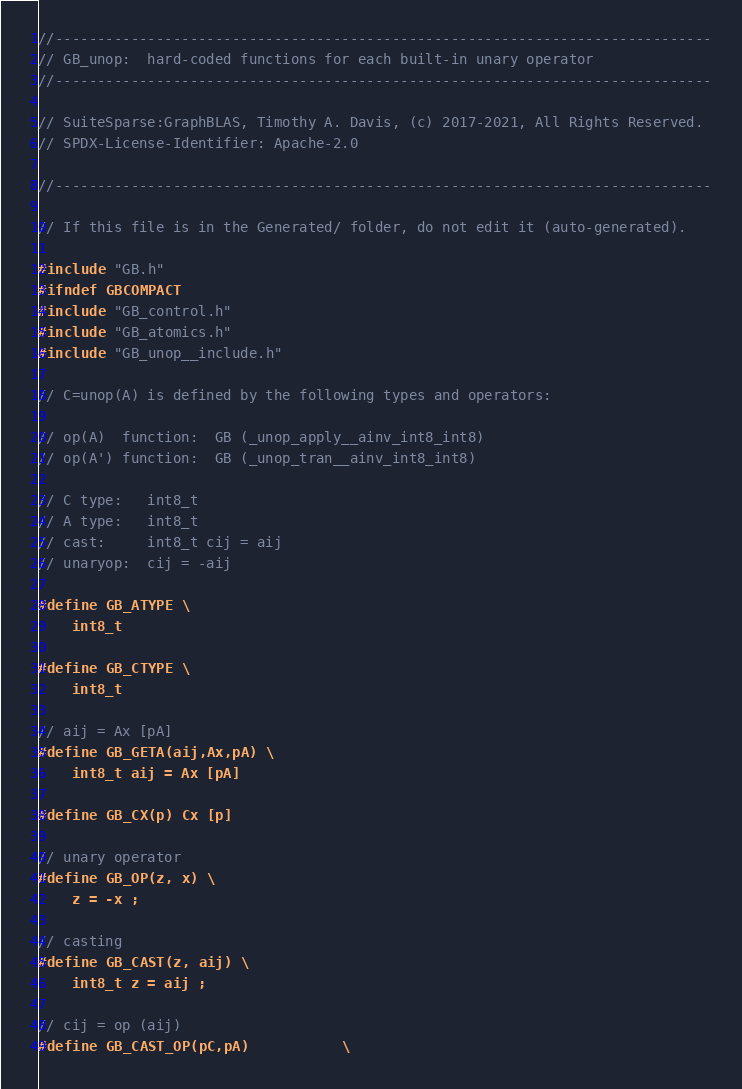<code> <loc_0><loc_0><loc_500><loc_500><_C_>//------------------------------------------------------------------------------
// GB_unop:  hard-coded functions for each built-in unary operator
//------------------------------------------------------------------------------

// SuiteSparse:GraphBLAS, Timothy A. Davis, (c) 2017-2021, All Rights Reserved.
// SPDX-License-Identifier: Apache-2.0

//------------------------------------------------------------------------------

// If this file is in the Generated/ folder, do not edit it (auto-generated).

#include "GB.h"
#ifndef GBCOMPACT
#include "GB_control.h"
#include "GB_atomics.h"
#include "GB_unop__include.h"

// C=unop(A) is defined by the following types and operators:

// op(A)  function:  GB (_unop_apply__ainv_int8_int8)
// op(A') function:  GB (_unop_tran__ainv_int8_int8)

// C type:   int8_t
// A type:   int8_t
// cast:     int8_t cij = aij
// unaryop:  cij = -aij

#define GB_ATYPE \
    int8_t

#define GB_CTYPE \
    int8_t

// aij = Ax [pA]
#define GB_GETA(aij,Ax,pA) \
    int8_t aij = Ax [pA]

#define GB_CX(p) Cx [p]

// unary operator
#define GB_OP(z, x) \
    z = -x ;

// casting
#define GB_CAST(z, aij) \
    int8_t z = aij ;

// cij = op (aij)
#define GB_CAST_OP(pC,pA)           \</code> 